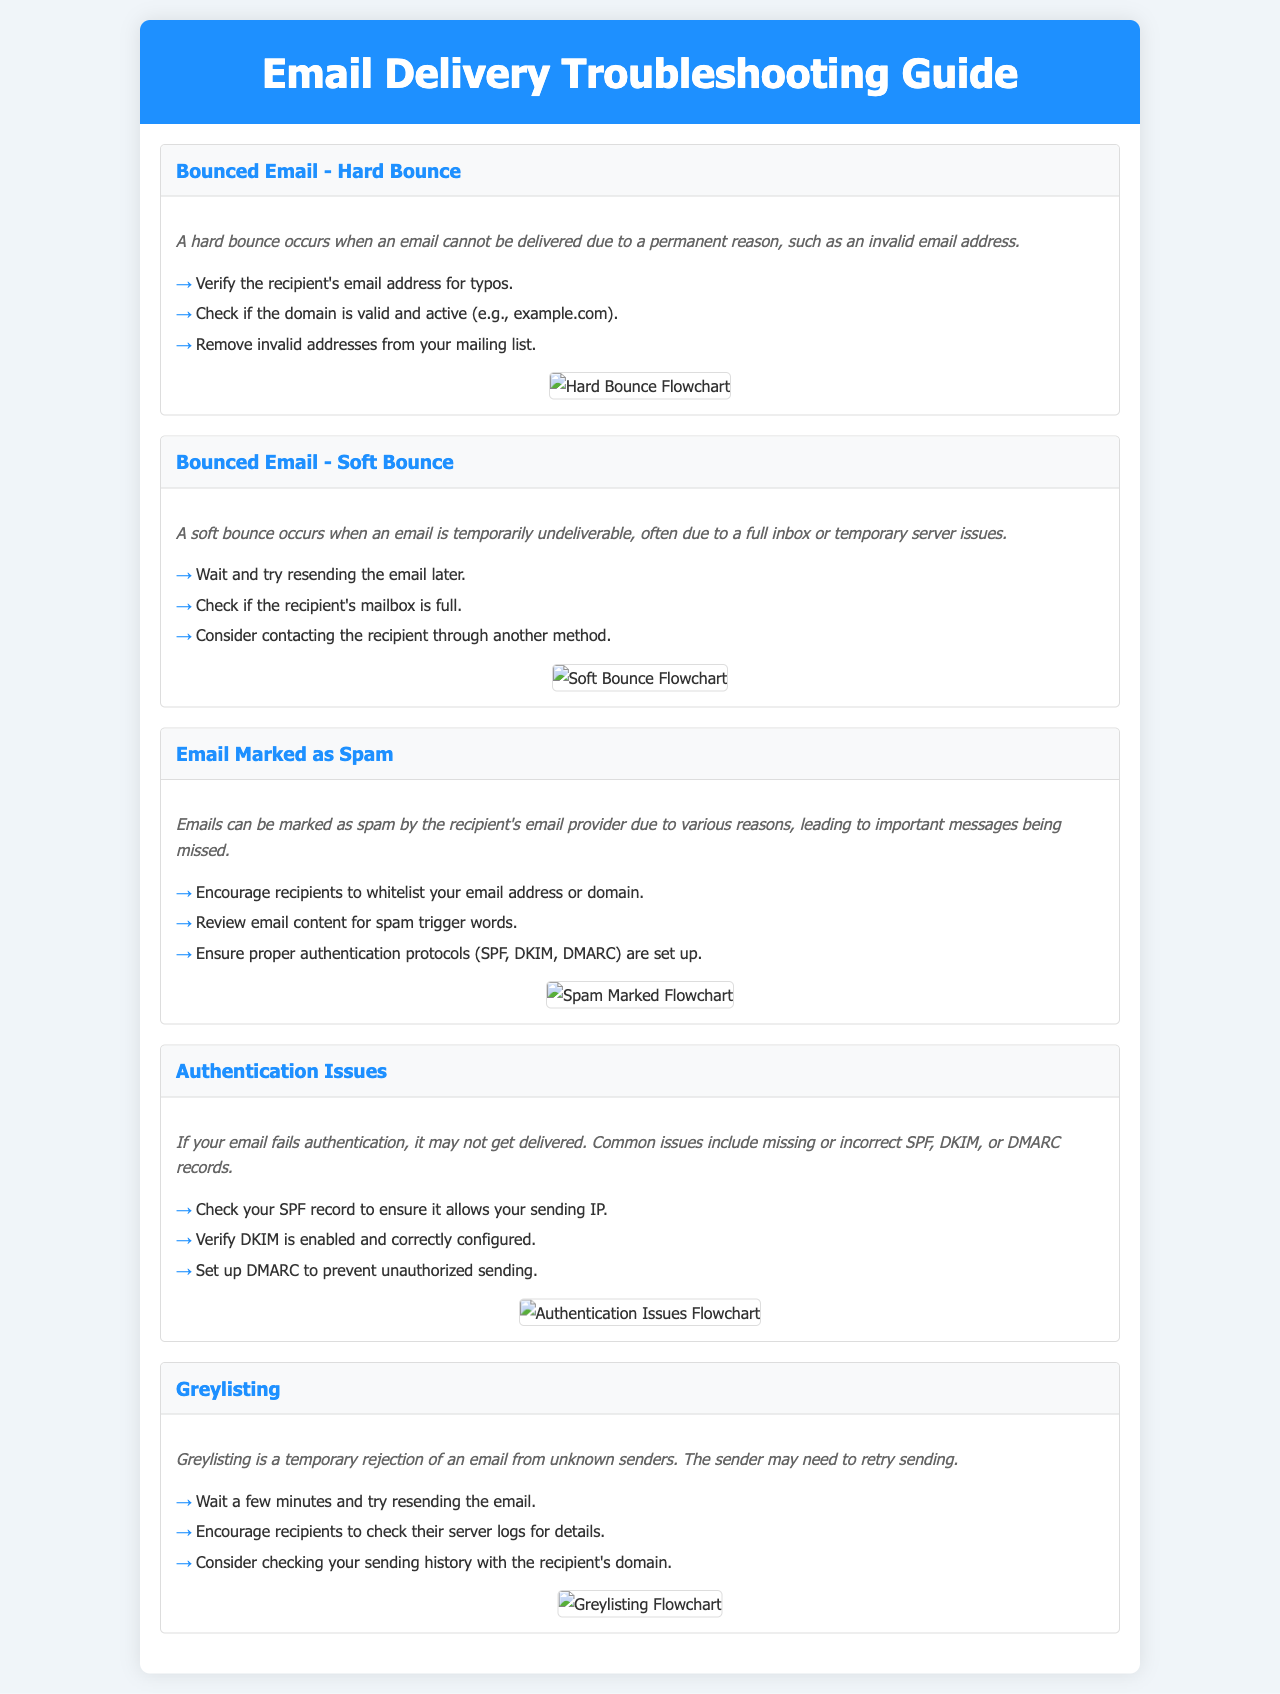What is a hard bounce? A hard bounce is an email that cannot be delivered due to a permanent reason, such as an invalid email address.
Answer: An invalid email address What should you check if an email is marked as spam? You should encourage recipients to whitelist your email address or domain.
Answer: Whitelist How many troubleshooting steps are listed for authentication issues? There are three troubleshooting steps listed for authentication issues.
Answer: Three What is greylisting? Greylisting is a temporary rejection of an email from unknown senders.
Answer: Temporary rejection What diagram is shown for soft bounce troubleshooting? The diagram displayed is a flowchart for soft bounce.
Answer: Soft Bounce Flowchart What is the first troubleshooting step for a hard bounce? The first troubleshooting step is to verify the recipient's email address for typos.
Answer: Verify the recipient's email address What should you do if a recipient's mailbox is full? You should consider contacting the recipient through another method.
Answer: Contact the recipient What authentication protocols are mentioned? The mentioned authentication protocols are SPF, DKIM, and DMARC.
Answer: SPF, DKIM, DMARC What does the error description for bounced email - soft bounce indicate? It indicates that a soft bounce occurs when an email is temporarily undeliverable, often due to a full inbox or temporary server issues.
Answer: Temporarily undeliverable 